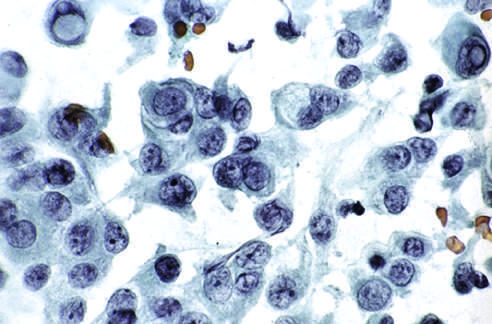what are visible in some of the aspirated cells?
Answer the question using a single word or phrase. Characteristic intranuclear inclusions 